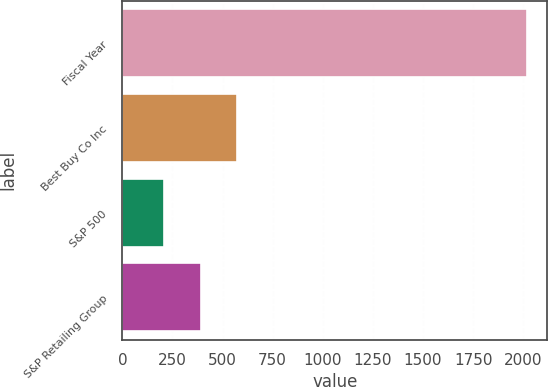Convert chart to OTSL. <chart><loc_0><loc_0><loc_500><loc_500><bar_chart><fcel>Fiscal Year<fcel>Best Buy Co Inc<fcel>S&P 500<fcel>S&P Retailing Group<nl><fcel>2018<fcel>570.98<fcel>209.22<fcel>390.1<nl></chart> 